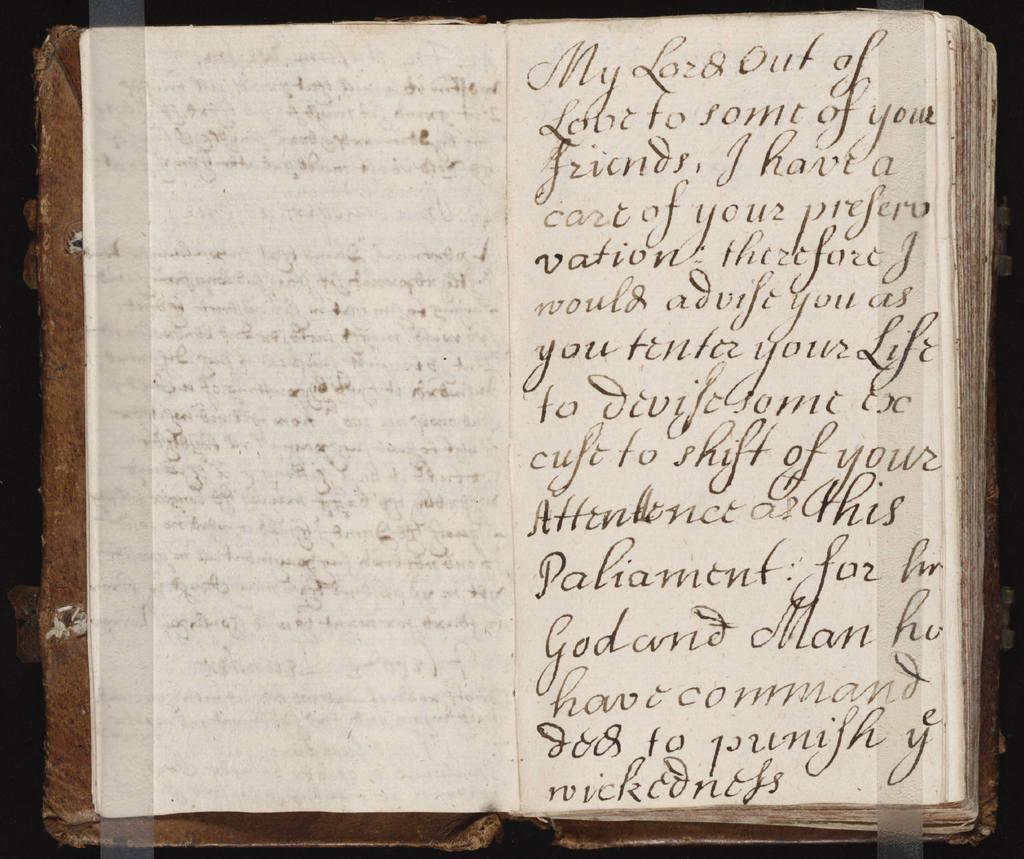What is the first letter of the first word?
Ensure brevity in your answer.  M. 